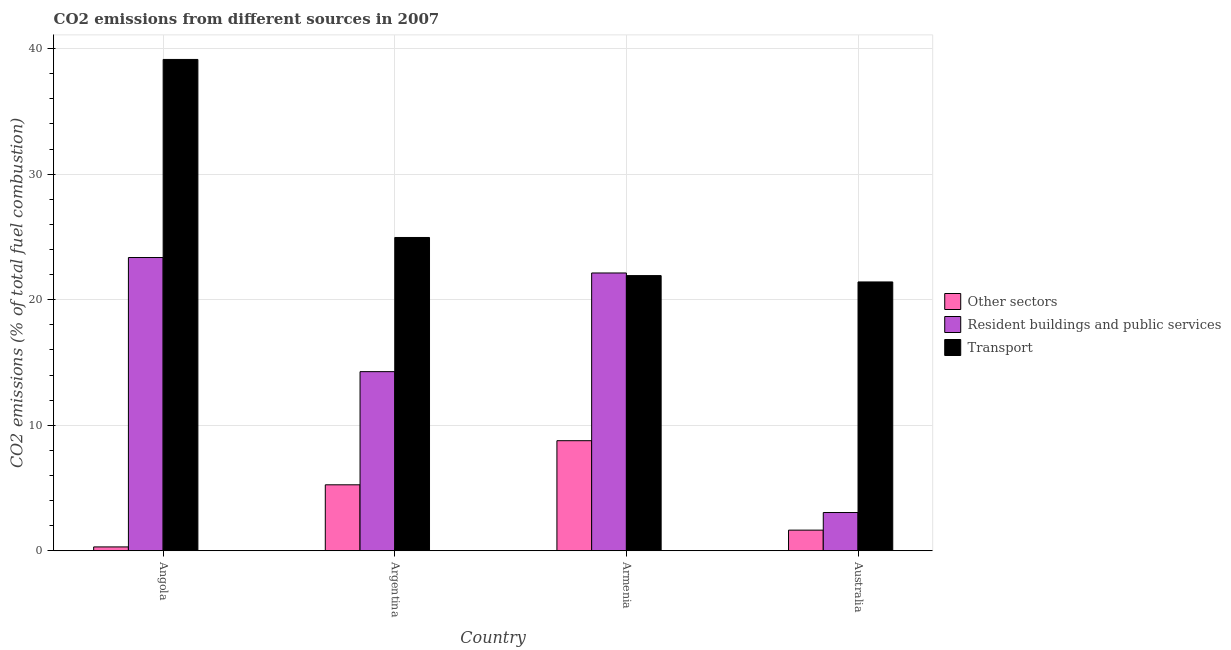How many different coloured bars are there?
Make the answer very short. 3. How many groups of bars are there?
Offer a terse response. 4. Are the number of bars on each tick of the X-axis equal?
Make the answer very short. Yes. How many bars are there on the 2nd tick from the left?
Provide a succinct answer. 3. What is the label of the 3rd group of bars from the left?
Keep it short and to the point. Armenia. What is the percentage of co2 emissions from other sectors in Argentina?
Make the answer very short. 5.25. Across all countries, what is the maximum percentage of co2 emissions from transport?
Offer a very short reply. 39.14. Across all countries, what is the minimum percentage of co2 emissions from resident buildings and public services?
Ensure brevity in your answer.  3.05. In which country was the percentage of co2 emissions from transport maximum?
Provide a succinct answer. Angola. What is the total percentage of co2 emissions from other sectors in the graph?
Offer a terse response. 15.97. What is the difference between the percentage of co2 emissions from other sectors in Angola and that in Armenia?
Keep it short and to the point. -8.46. What is the difference between the percentage of co2 emissions from other sectors in Australia and the percentage of co2 emissions from transport in Armenia?
Provide a short and direct response. -20.28. What is the average percentage of co2 emissions from resident buildings and public services per country?
Your answer should be compact. 15.7. What is the difference between the percentage of co2 emissions from transport and percentage of co2 emissions from resident buildings and public services in Angola?
Give a very brief answer. 15.78. In how many countries, is the percentage of co2 emissions from resident buildings and public services greater than 2 %?
Provide a short and direct response. 4. What is the ratio of the percentage of co2 emissions from transport in Angola to that in Australia?
Offer a terse response. 1.83. Is the percentage of co2 emissions from other sectors in Armenia less than that in Australia?
Offer a terse response. No. Is the difference between the percentage of co2 emissions from resident buildings and public services in Argentina and Australia greater than the difference between the percentage of co2 emissions from other sectors in Argentina and Australia?
Give a very brief answer. Yes. What is the difference between the highest and the second highest percentage of co2 emissions from other sectors?
Offer a very short reply. 3.51. What is the difference between the highest and the lowest percentage of co2 emissions from transport?
Give a very brief answer. 17.72. Is the sum of the percentage of co2 emissions from resident buildings and public services in Angola and Armenia greater than the maximum percentage of co2 emissions from other sectors across all countries?
Keep it short and to the point. Yes. What does the 2nd bar from the left in Armenia represents?
Provide a succinct answer. Resident buildings and public services. What does the 3rd bar from the right in Argentina represents?
Keep it short and to the point. Other sectors. Is it the case that in every country, the sum of the percentage of co2 emissions from other sectors and percentage of co2 emissions from resident buildings and public services is greater than the percentage of co2 emissions from transport?
Make the answer very short. No. Are all the bars in the graph horizontal?
Offer a terse response. No. How many countries are there in the graph?
Offer a terse response. 4. What is the difference between two consecutive major ticks on the Y-axis?
Provide a short and direct response. 10. Are the values on the major ticks of Y-axis written in scientific E-notation?
Ensure brevity in your answer.  No. Does the graph contain any zero values?
Make the answer very short. No. Does the graph contain grids?
Provide a succinct answer. Yes. Where does the legend appear in the graph?
Your answer should be compact. Center right. How are the legend labels stacked?
Your response must be concise. Vertical. What is the title of the graph?
Give a very brief answer. CO2 emissions from different sources in 2007. Does "Secondary education" appear as one of the legend labels in the graph?
Your answer should be very brief. No. What is the label or title of the X-axis?
Your response must be concise. Country. What is the label or title of the Y-axis?
Ensure brevity in your answer.  CO2 emissions (% of total fuel combustion). What is the CO2 emissions (% of total fuel combustion) in Other sectors in Angola?
Your response must be concise. 0.31. What is the CO2 emissions (% of total fuel combustion) of Resident buildings and public services in Angola?
Give a very brief answer. 23.36. What is the CO2 emissions (% of total fuel combustion) in Transport in Angola?
Offer a terse response. 39.14. What is the CO2 emissions (% of total fuel combustion) in Other sectors in Argentina?
Provide a succinct answer. 5.25. What is the CO2 emissions (% of total fuel combustion) in Resident buildings and public services in Argentina?
Make the answer very short. 14.27. What is the CO2 emissions (% of total fuel combustion) of Transport in Argentina?
Ensure brevity in your answer.  24.96. What is the CO2 emissions (% of total fuel combustion) in Other sectors in Armenia?
Make the answer very short. 8.77. What is the CO2 emissions (% of total fuel combustion) in Resident buildings and public services in Armenia?
Ensure brevity in your answer.  22.13. What is the CO2 emissions (% of total fuel combustion) of Transport in Armenia?
Offer a very short reply. 21.92. What is the CO2 emissions (% of total fuel combustion) in Other sectors in Australia?
Keep it short and to the point. 1.64. What is the CO2 emissions (% of total fuel combustion) of Resident buildings and public services in Australia?
Your answer should be very brief. 3.05. What is the CO2 emissions (% of total fuel combustion) of Transport in Australia?
Keep it short and to the point. 21.41. Across all countries, what is the maximum CO2 emissions (% of total fuel combustion) in Other sectors?
Your response must be concise. 8.77. Across all countries, what is the maximum CO2 emissions (% of total fuel combustion) in Resident buildings and public services?
Give a very brief answer. 23.36. Across all countries, what is the maximum CO2 emissions (% of total fuel combustion) of Transport?
Offer a terse response. 39.14. Across all countries, what is the minimum CO2 emissions (% of total fuel combustion) of Other sectors?
Ensure brevity in your answer.  0.31. Across all countries, what is the minimum CO2 emissions (% of total fuel combustion) of Resident buildings and public services?
Ensure brevity in your answer.  3.05. Across all countries, what is the minimum CO2 emissions (% of total fuel combustion) of Transport?
Give a very brief answer. 21.41. What is the total CO2 emissions (% of total fuel combustion) in Other sectors in the graph?
Provide a short and direct response. 15.97. What is the total CO2 emissions (% of total fuel combustion) in Resident buildings and public services in the graph?
Provide a succinct answer. 62.81. What is the total CO2 emissions (% of total fuel combustion) in Transport in the graph?
Your answer should be very brief. 107.43. What is the difference between the CO2 emissions (% of total fuel combustion) of Other sectors in Angola and that in Argentina?
Make the answer very short. -4.95. What is the difference between the CO2 emissions (% of total fuel combustion) in Resident buildings and public services in Angola and that in Argentina?
Your answer should be very brief. 9.09. What is the difference between the CO2 emissions (% of total fuel combustion) in Transport in Angola and that in Argentina?
Your answer should be compact. 14.18. What is the difference between the CO2 emissions (% of total fuel combustion) of Other sectors in Angola and that in Armenia?
Give a very brief answer. -8.46. What is the difference between the CO2 emissions (% of total fuel combustion) of Resident buildings and public services in Angola and that in Armenia?
Make the answer very short. 1.23. What is the difference between the CO2 emissions (% of total fuel combustion) of Transport in Angola and that in Armenia?
Offer a very short reply. 17.22. What is the difference between the CO2 emissions (% of total fuel combustion) of Other sectors in Angola and that in Australia?
Provide a succinct answer. -1.34. What is the difference between the CO2 emissions (% of total fuel combustion) in Resident buildings and public services in Angola and that in Australia?
Provide a succinct answer. 20.31. What is the difference between the CO2 emissions (% of total fuel combustion) of Transport in Angola and that in Australia?
Provide a succinct answer. 17.72. What is the difference between the CO2 emissions (% of total fuel combustion) of Other sectors in Argentina and that in Armenia?
Keep it short and to the point. -3.51. What is the difference between the CO2 emissions (% of total fuel combustion) of Resident buildings and public services in Argentina and that in Armenia?
Give a very brief answer. -7.86. What is the difference between the CO2 emissions (% of total fuel combustion) in Transport in Argentina and that in Armenia?
Offer a very short reply. 3.04. What is the difference between the CO2 emissions (% of total fuel combustion) of Other sectors in Argentina and that in Australia?
Ensure brevity in your answer.  3.61. What is the difference between the CO2 emissions (% of total fuel combustion) of Resident buildings and public services in Argentina and that in Australia?
Your answer should be compact. 11.22. What is the difference between the CO2 emissions (% of total fuel combustion) of Transport in Argentina and that in Australia?
Provide a short and direct response. 3.54. What is the difference between the CO2 emissions (% of total fuel combustion) in Other sectors in Armenia and that in Australia?
Make the answer very short. 7.12. What is the difference between the CO2 emissions (% of total fuel combustion) in Resident buildings and public services in Armenia and that in Australia?
Make the answer very short. 19.08. What is the difference between the CO2 emissions (% of total fuel combustion) in Transport in Armenia and that in Australia?
Keep it short and to the point. 0.51. What is the difference between the CO2 emissions (% of total fuel combustion) in Other sectors in Angola and the CO2 emissions (% of total fuel combustion) in Resident buildings and public services in Argentina?
Provide a succinct answer. -13.96. What is the difference between the CO2 emissions (% of total fuel combustion) in Other sectors in Angola and the CO2 emissions (% of total fuel combustion) in Transport in Argentina?
Your answer should be compact. -24.65. What is the difference between the CO2 emissions (% of total fuel combustion) in Resident buildings and public services in Angola and the CO2 emissions (% of total fuel combustion) in Transport in Argentina?
Offer a very short reply. -1.6. What is the difference between the CO2 emissions (% of total fuel combustion) of Other sectors in Angola and the CO2 emissions (% of total fuel combustion) of Resident buildings and public services in Armenia?
Give a very brief answer. -21.82. What is the difference between the CO2 emissions (% of total fuel combustion) of Other sectors in Angola and the CO2 emissions (% of total fuel combustion) of Transport in Armenia?
Offer a very short reply. -21.61. What is the difference between the CO2 emissions (% of total fuel combustion) of Resident buildings and public services in Angola and the CO2 emissions (% of total fuel combustion) of Transport in Armenia?
Your response must be concise. 1.44. What is the difference between the CO2 emissions (% of total fuel combustion) in Other sectors in Angola and the CO2 emissions (% of total fuel combustion) in Resident buildings and public services in Australia?
Provide a succinct answer. -2.74. What is the difference between the CO2 emissions (% of total fuel combustion) in Other sectors in Angola and the CO2 emissions (% of total fuel combustion) in Transport in Australia?
Offer a terse response. -21.11. What is the difference between the CO2 emissions (% of total fuel combustion) in Resident buildings and public services in Angola and the CO2 emissions (% of total fuel combustion) in Transport in Australia?
Make the answer very short. 1.95. What is the difference between the CO2 emissions (% of total fuel combustion) of Other sectors in Argentina and the CO2 emissions (% of total fuel combustion) of Resident buildings and public services in Armenia?
Keep it short and to the point. -16.87. What is the difference between the CO2 emissions (% of total fuel combustion) of Other sectors in Argentina and the CO2 emissions (% of total fuel combustion) of Transport in Armenia?
Provide a succinct answer. -16.67. What is the difference between the CO2 emissions (% of total fuel combustion) of Resident buildings and public services in Argentina and the CO2 emissions (% of total fuel combustion) of Transport in Armenia?
Offer a terse response. -7.65. What is the difference between the CO2 emissions (% of total fuel combustion) of Other sectors in Argentina and the CO2 emissions (% of total fuel combustion) of Resident buildings and public services in Australia?
Provide a short and direct response. 2.21. What is the difference between the CO2 emissions (% of total fuel combustion) in Other sectors in Argentina and the CO2 emissions (% of total fuel combustion) in Transport in Australia?
Your answer should be compact. -16.16. What is the difference between the CO2 emissions (% of total fuel combustion) of Resident buildings and public services in Argentina and the CO2 emissions (% of total fuel combustion) of Transport in Australia?
Offer a very short reply. -7.14. What is the difference between the CO2 emissions (% of total fuel combustion) of Other sectors in Armenia and the CO2 emissions (% of total fuel combustion) of Resident buildings and public services in Australia?
Offer a very short reply. 5.72. What is the difference between the CO2 emissions (% of total fuel combustion) in Other sectors in Armenia and the CO2 emissions (% of total fuel combustion) in Transport in Australia?
Your answer should be compact. -12.65. What is the difference between the CO2 emissions (% of total fuel combustion) in Resident buildings and public services in Armenia and the CO2 emissions (% of total fuel combustion) in Transport in Australia?
Keep it short and to the point. 0.71. What is the average CO2 emissions (% of total fuel combustion) in Other sectors per country?
Give a very brief answer. 3.99. What is the average CO2 emissions (% of total fuel combustion) in Resident buildings and public services per country?
Make the answer very short. 15.7. What is the average CO2 emissions (% of total fuel combustion) of Transport per country?
Make the answer very short. 26.86. What is the difference between the CO2 emissions (% of total fuel combustion) in Other sectors and CO2 emissions (% of total fuel combustion) in Resident buildings and public services in Angola?
Your answer should be compact. -23.05. What is the difference between the CO2 emissions (% of total fuel combustion) of Other sectors and CO2 emissions (% of total fuel combustion) of Transport in Angola?
Your response must be concise. -38.83. What is the difference between the CO2 emissions (% of total fuel combustion) of Resident buildings and public services and CO2 emissions (% of total fuel combustion) of Transport in Angola?
Your answer should be compact. -15.78. What is the difference between the CO2 emissions (% of total fuel combustion) of Other sectors and CO2 emissions (% of total fuel combustion) of Resident buildings and public services in Argentina?
Make the answer very short. -9.01. What is the difference between the CO2 emissions (% of total fuel combustion) of Other sectors and CO2 emissions (% of total fuel combustion) of Transport in Argentina?
Your response must be concise. -19.7. What is the difference between the CO2 emissions (% of total fuel combustion) of Resident buildings and public services and CO2 emissions (% of total fuel combustion) of Transport in Argentina?
Give a very brief answer. -10.69. What is the difference between the CO2 emissions (% of total fuel combustion) in Other sectors and CO2 emissions (% of total fuel combustion) in Resident buildings and public services in Armenia?
Your answer should be compact. -13.36. What is the difference between the CO2 emissions (% of total fuel combustion) in Other sectors and CO2 emissions (% of total fuel combustion) in Transport in Armenia?
Ensure brevity in your answer.  -13.15. What is the difference between the CO2 emissions (% of total fuel combustion) of Resident buildings and public services and CO2 emissions (% of total fuel combustion) of Transport in Armenia?
Offer a terse response. 0.21. What is the difference between the CO2 emissions (% of total fuel combustion) in Other sectors and CO2 emissions (% of total fuel combustion) in Resident buildings and public services in Australia?
Give a very brief answer. -1.4. What is the difference between the CO2 emissions (% of total fuel combustion) of Other sectors and CO2 emissions (% of total fuel combustion) of Transport in Australia?
Offer a terse response. -19.77. What is the difference between the CO2 emissions (% of total fuel combustion) in Resident buildings and public services and CO2 emissions (% of total fuel combustion) in Transport in Australia?
Make the answer very short. -18.37. What is the ratio of the CO2 emissions (% of total fuel combustion) of Other sectors in Angola to that in Argentina?
Keep it short and to the point. 0.06. What is the ratio of the CO2 emissions (% of total fuel combustion) in Resident buildings and public services in Angola to that in Argentina?
Provide a succinct answer. 1.64. What is the ratio of the CO2 emissions (% of total fuel combustion) in Transport in Angola to that in Argentina?
Keep it short and to the point. 1.57. What is the ratio of the CO2 emissions (% of total fuel combustion) of Other sectors in Angola to that in Armenia?
Offer a terse response. 0.04. What is the ratio of the CO2 emissions (% of total fuel combustion) in Resident buildings and public services in Angola to that in Armenia?
Make the answer very short. 1.06. What is the ratio of the CO2 emissions (% of total fuel combustion) of Transport in Angola to that in Armenia?
Ensure brevity in your answer.  1.79. What is the ratio of the CO2 emissions (% of total fuel combustion) in Other sectors in Angola to that in Australia?
Provide a short and direct response. 0.19. What is the ratio of the CO2 emissions (% of total fuel combustion) of Resident buildings and public services in Angola to that in Australia?
Offer a terse response. 7.67. What is the ratio of the CO2 emissions (% of total fuel combustion) of Transport in Angola to that in Australia?
Your answer should be very brief. 1.83. What is the ratio of the CO2 emissions (% of total fuel combustion) in Other sectors in Argentina to that in Armenia?
Provide a short and direct response. 0.6. What is the ratio of the CO2 emissions (% of total fuel combustion) of Resident buildings and public services in Argentina to that in Armenia?
Your answer should be very brief. 0.64. What is the ratio of the CO2 emissions (% of total fuel combustion) of Transport in Argentina to that in Armenia?
Keep it short and to the point. 1.14. What is the ratio of the CO2 emissions (% of total fuel combustion) of Other sectors in Argentina to that in Australia?
Offer a very short reply. 3.2. What is the ratio of the CO2 emissions (% of total fuel combustion) of Resident buildings and public services in Argentina to that in Australia?
Your response must be concise. 4.68. What is the ratio of the CO2 emissions (% of total fuel combustion) in Transport in Argentina to that in Australia?
Ensure brevity in your answer.  1.17. What is the ratio of the CO2 emissions (% of total fuel combustion) of Other sectors in Armenia to that in Australia?
Your answer should be compact. 5.33. What is the ratio of the CO2 emissions (% of total fuel combustion) of Resident buildings and public services in Armenia to that in Australia?
Ensure brevity in your answer.  7.26. What is the ratio of the CO2 emissions (% of total fuel combustion) in Transport in Armenia to that in Australia?
Give a very brief answer. 1.02. What is the difference between the highest and the second highest CO2 emissions (% of total fuel combustion) of Other sectors?
Your answer should be compact. 3.51. What is the difference between the highest and the second highest CO2 emissions (% of total fuel combustion) in Resident buildings and public services?
Your answer should be compact. 1.23. What is the difference between the highest and the second highest CO2 emissions (% of total fuel combustion) in Transport?
Provide a short and direct response. 14.18. What is the difference between the highest and the lowest CO2 emissions (% of total fuel combustion) of Other sectors?
Offer a terse response. 8.46. What is the difference between the highest and the lowest CO2 emissions (% of total fuel combustion) in Resident buildings and public services?
Ensure brevity in your answer.  20.31. What is the difference between the highest and the lowest CO2 emissions (% of total fuel combustion) in Transport?
Make the answer very short. 17.72. 